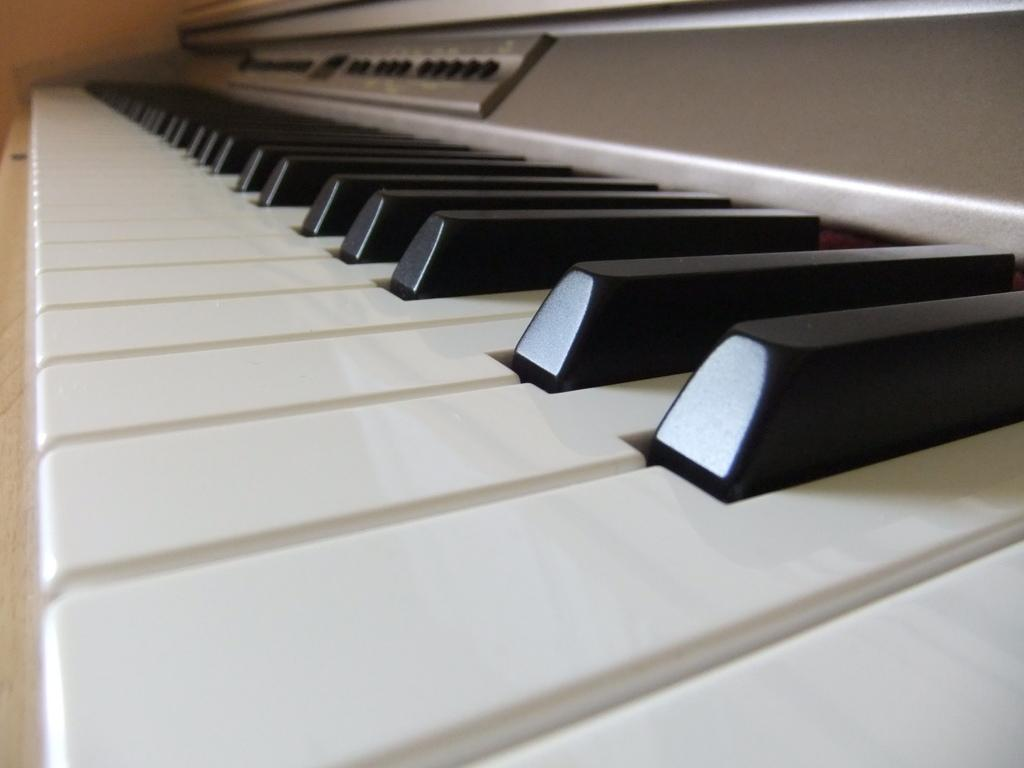What is the main object in the image? There is a piano in the image. Is the piano being used by a spy in the image? There is no indication of a spy or any espionage activity in the image; it simply features a piano. 